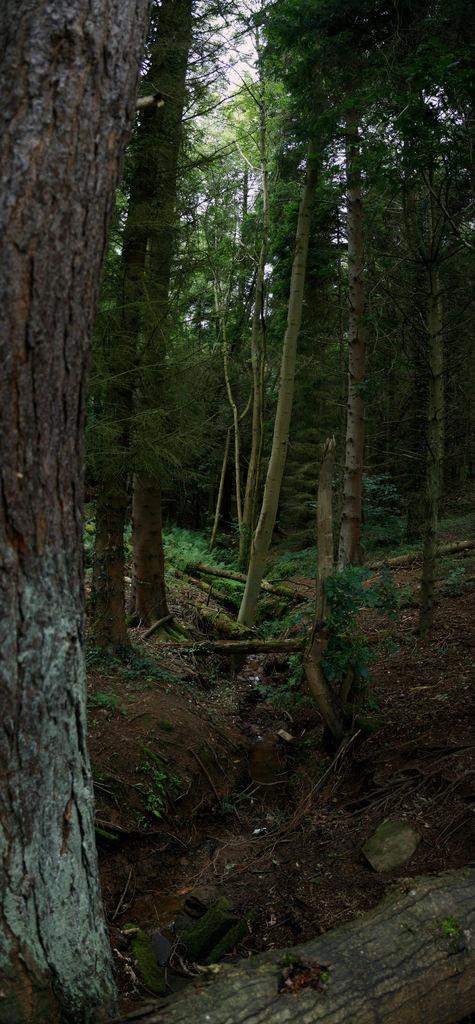What type of vegetation can be seen in the image? There is grass in the image. What other natural elements are present in the image? There are trees in the image. What can be seen above the trees and grass in the image? The sky is visible in the image. What type of yoke can be seen in the image? There is no yoke present in the image. What kind of blade is being used to cut the grass in the image? There is no blade or grass-cutting activity depicted in the image. 